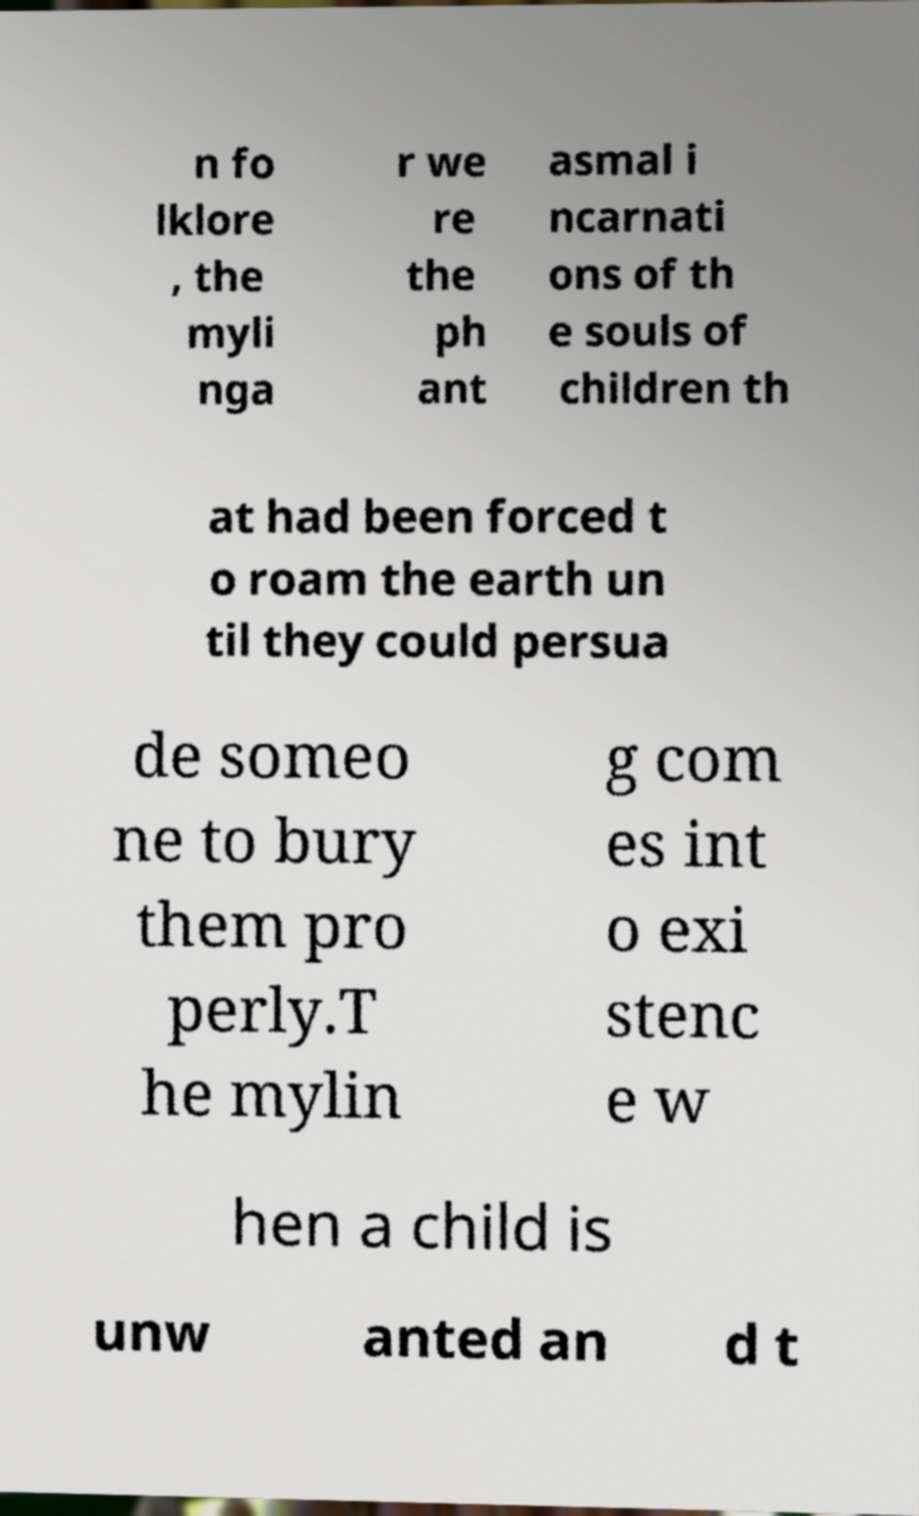What messages or text are displayed in this image? I need them in a readable, typed format. n fo lklore , the myli nga r we re the ph ant asmal i ncarnati ons of th e souls of children th at had been forced t o roam the earth un til they could persua de someo ne to bury them pro perly.T he mylin g com es int o exi stenc e w hen a child is unw anted an d t 